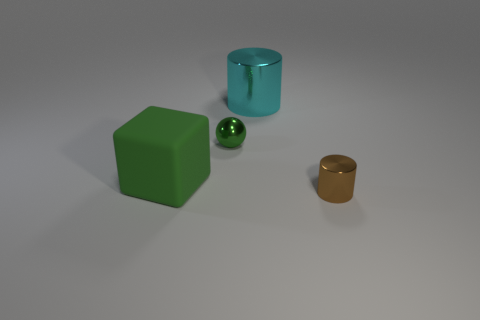There is a tiny sphere that is the same material as the small brown cylinder; what color is it?
Offer a terse response. Green. There is a thing that is behind the tiny metallic sphere; are there any green metal spheres that are to the left of it?
Ensure brevity in your answer.  Yes. There is a metal object that is the same size as the block; what is its color?
Give a very brief answer. Cyan. How many objects are either small green metal objects or big green rubber blocks?
Provide a short and direct response. 2. What is the size of the green thing behind the green thing that is in front of the green metal object that is behind the green block?
Provide a succinct answer. Small. How many big objects are the same color as the big block?
Provide a short and direct response. 0. How many tiny cylinders are made of the same material as the tiny sphere?
Your answer should be very brief. 1. What number of things are either small metallic balls or things behind the green matte cube?
Your answer should be very brief. 2. What color is the cylinder in front of the metallic object that is on the left side of the cylinder that is left of the tiny brown object?
Give a very brief answer. Brown. How big is the object in front of the cube?
Keep it short and to the point. Small. 